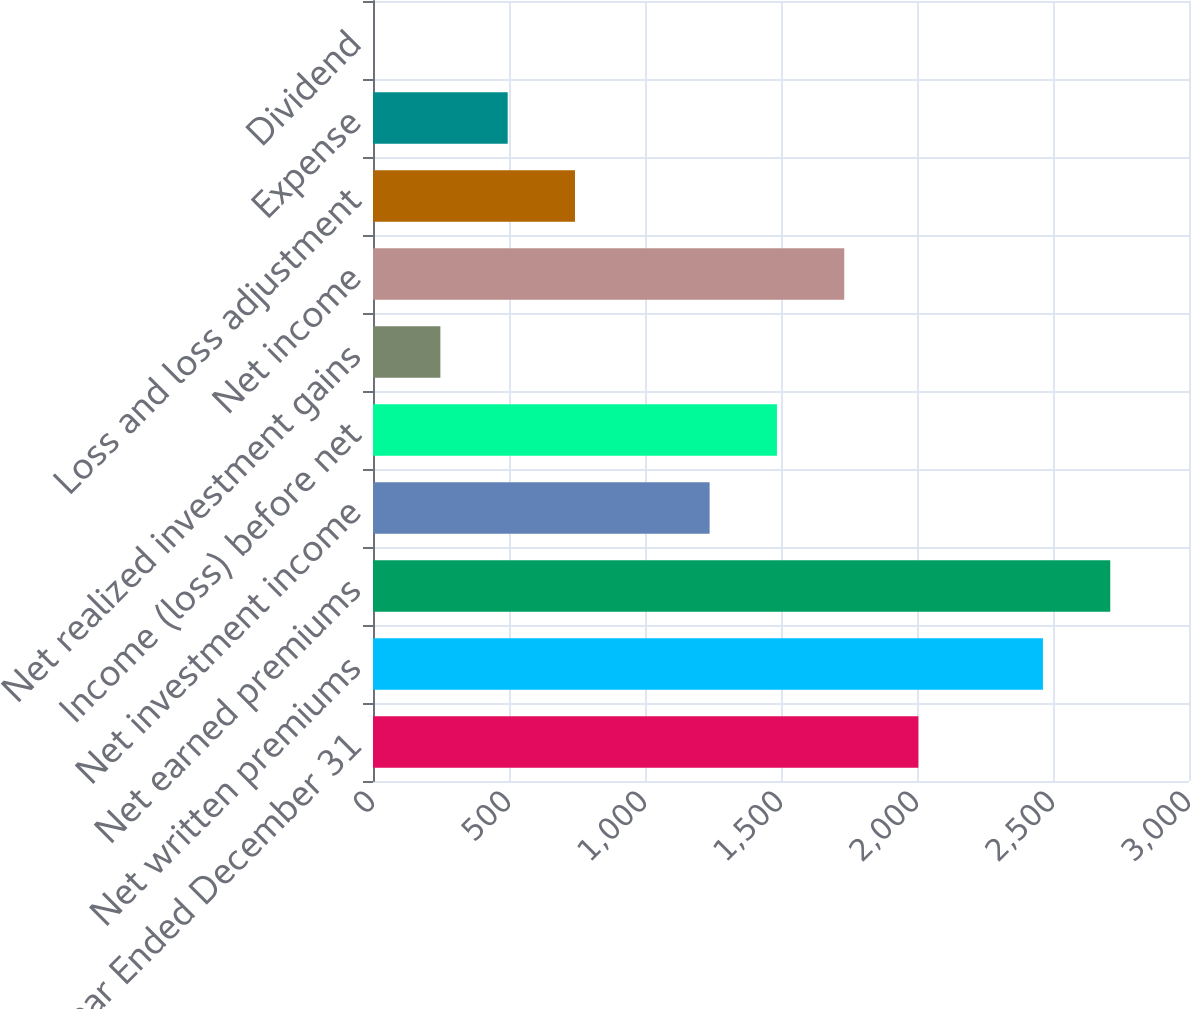<chart> <loc_0><loc_0><loc_500><loc_500><bar_chart><fcel>Year Ended December 31<fcel>Net written premiums<fcel>Net earned premiums<fcel>Net investment income<fcel>Income (loss) before net<fcel>Net realized investment gains<fcel>Net income<fcel>Loss and loss adjustment<fcel>Expense<fcel>Dividend<nl><fcel>2005<fcel>2463<fcel>2710.48<fcel>1237.6<fcel>1485.08<fcel>247.68<fcel>1732.56<fcel>742.64<fcel>495.16<fcel>0.2<nl></chart> 